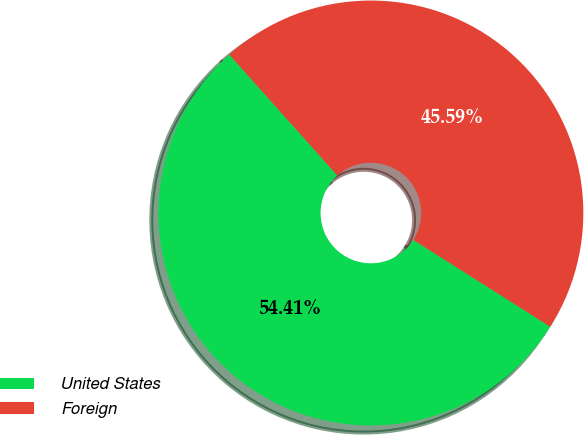Convert chart. <chart><loc_0><loc_0><loc_500><loc_500><pie_chart><fcel>United States<fcel>Foreign<nl><fcel>54.41%<fcel>45.59%<nl></chart> 